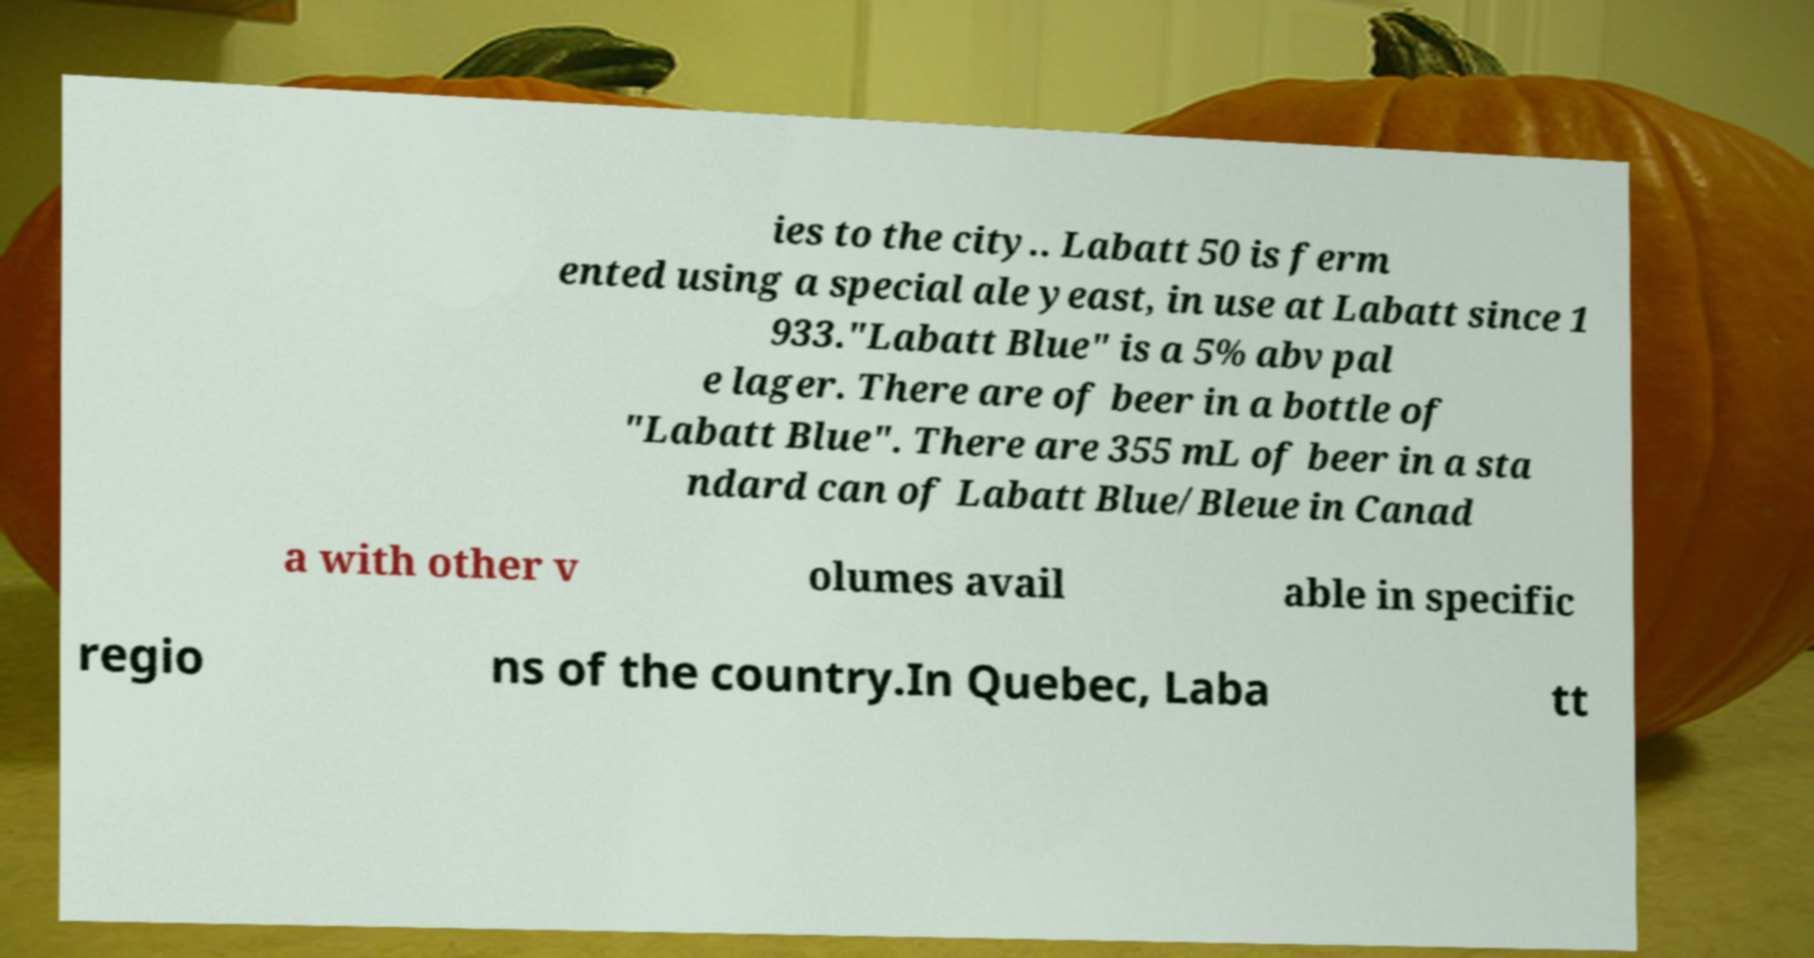What messages or text are displayed in this image? I need them in a readable, typed format. ies to the city.. Labatt 50 is ferm ented using a special ale yeast, in use at Labatt since 1 933."Labatt Blue" is a 5% abv pal e lager. There are of beer in a bottle of "Labatt Blue". There are 355 mL of beer in a sta ndard can of Labatt Blue/Bleue in Canad a with other v olumes avail able in specific regio ns of the country.In Quebec, Laba tt 